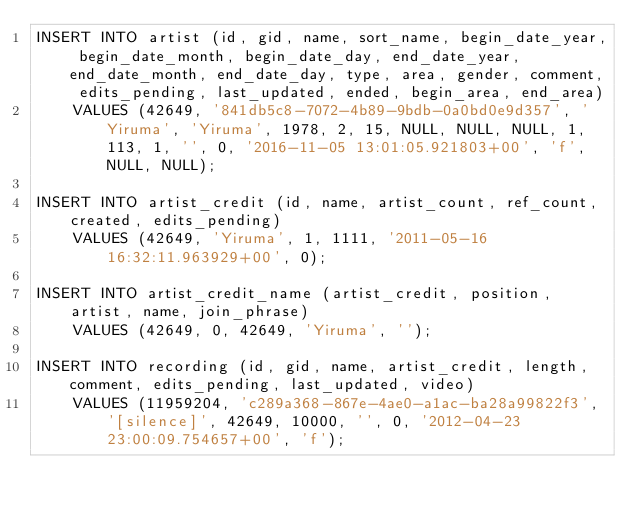Convert code to text. <code><loc_0><loc_0><loc_500><loc_500><_SQL_>INSERT INTO artist (id, gid, name, sort_name, begin_date_year, begin_date_month, begin_date_day, end_date_year, end_date_month, end_date_day, type, area, gender, comment, edits_pending, last_updated, ended, begin_area, end_area)
    VALUES (42649, '841db5c8-7072-4b89-9bdb-0a0bd0e9d357', 'Yiruma', 'Yiruma', 1978, 2, 15, NULL, NULL, NULL, 1, 113, 1, '', 0, '2016-11-05 13:01:05.921803+00', 'f', NULL, NULL);

INSERT INTO artist_credit (id, name, artist_count, ref_count, created, edits_pending)
    VALUES (42649, 'Yiruma', 1, 1111, '2011-05-16 16:32:11.963929+00', 0);

INSERT INTO artist_credit_name (artist_credit, position, artist, name, join_phrase)
    VALUES (42649, 0, 42649, 'Yiruma', '');

INSERT INTO recording (id, gid, name, artist_credit, length, comment, edits_pending, last_updated, video)
    VALUES (11959204, 'c289a368-867e-4ae0-a1ac-ba28a99822f3', '[silence]', 42649, 10000, '', 0, '2012-04-23 23:00:09.754657+00', 'f');
</code> 